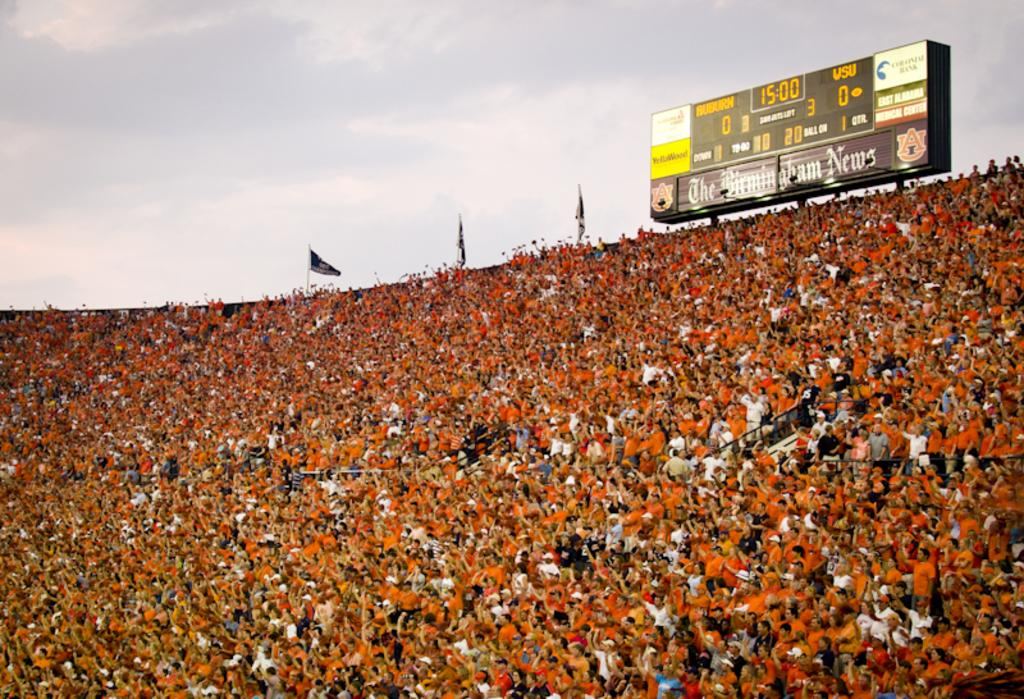<image>
Render a clear and concise summary of the photo. A very large crowd in front of a score board advertising The Birmingham News. 